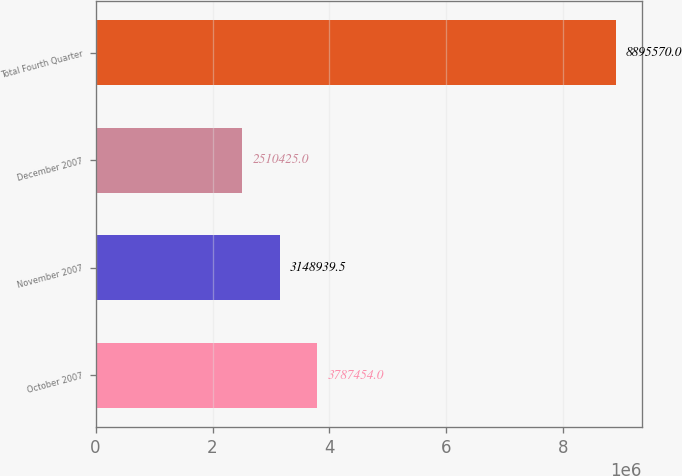Convert chart. <chart><loc_0><loc_0><loc_500><loc_500><bar_chart><fcel>October 2007<fcel>November 2007<fcel>December 2007<fcel>Total Fourth Quarter<nl><fcel>3.78745e+06<fcel>3.14894e+06<fcel>2.51042e+06<fcel>8.89557e+06<nl></chart> 